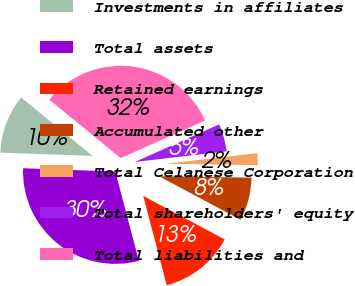<chart> <loc_0><loc_0><loc_500><loc_500><pie_chart><fcel>Investments in affiliates<fcel>Total assets<fcel>Retained earnings<fcel>Accumulated other<fcel>Total Celanese Corporation<fcel>Total shareholders' equity<fcel>Total liabilities and<nl><fcel>10.34%<fcel>29.66%<fcel>13.1%<fcel>7.58%<fcel>2.07%<fcel>4.83%<fcel>32.42%<nl></chart> 